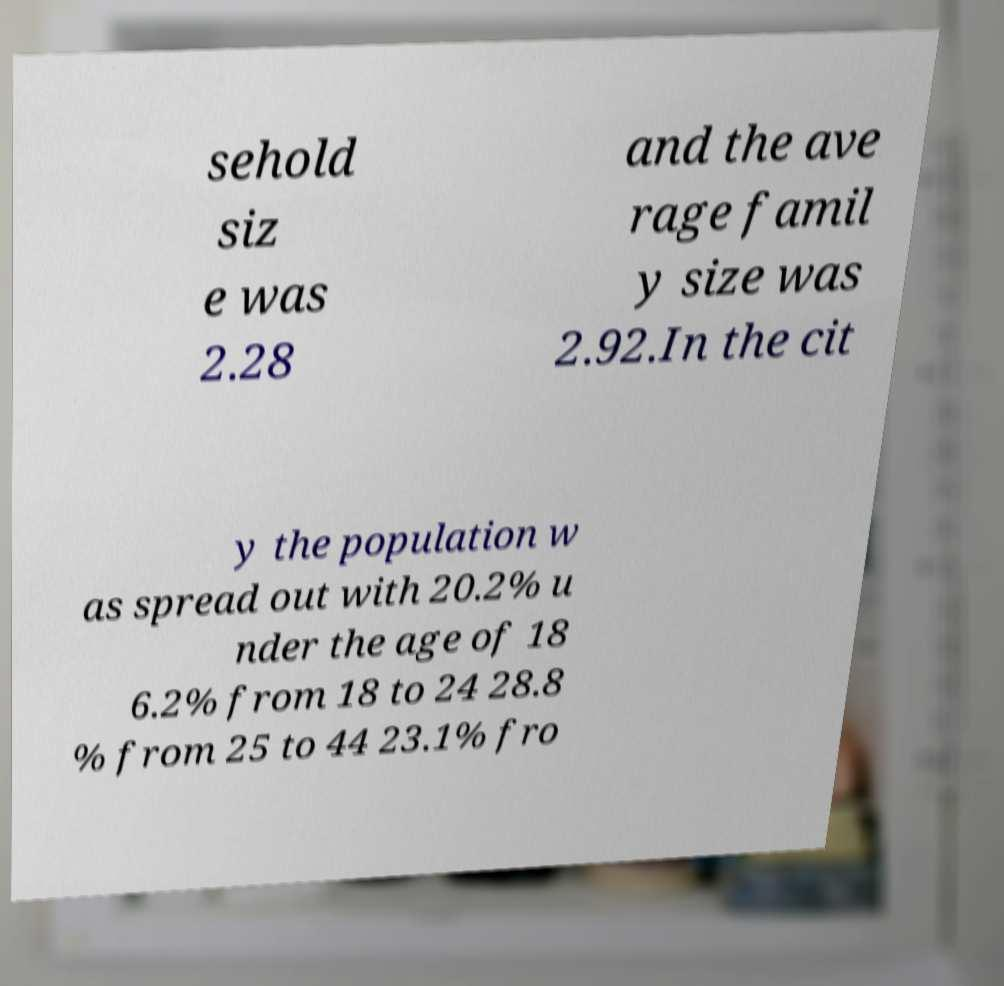I need the written content from this picture converted into text. Can you do that? sehold siz e was 2.28 and the ave rage famil y size was 2.92.In the cit y the population w as spread out with 20.2% u nder the age of 18 6.2% from 18 to 24 28.8 % from 25 to 44 23.1% fro 